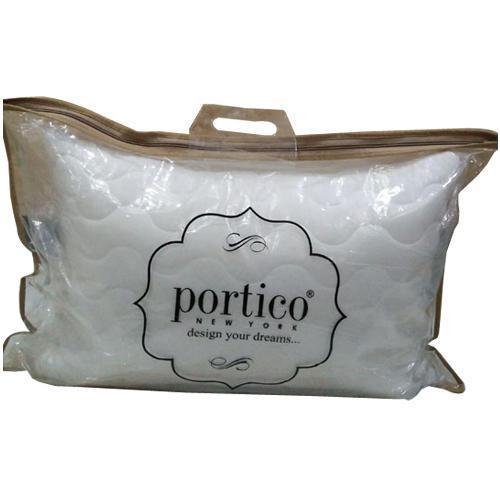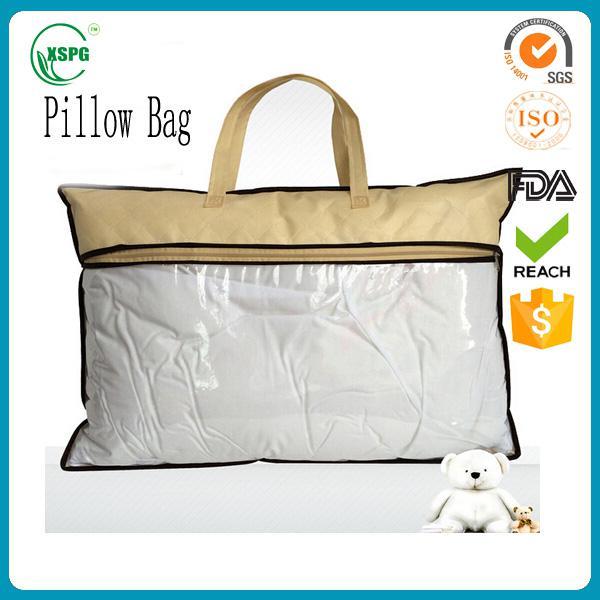The first image is the image on the left, the second image is the image on the right. Examine the images to the left and right. Is the description "Each image shows a pillow bag with at least one handle, and one image displays a bag head-on, while the other displays a bag at an angle." accurate? Answer yes or no. No. The first image is the image on the left, the second image is the image on the right. Analyze the images presented: Is the assertion "In at least one image there is a pillow in a plastic zip bag that has gold plastic on the top fourth." valid? Answer yes or no. Yes. 